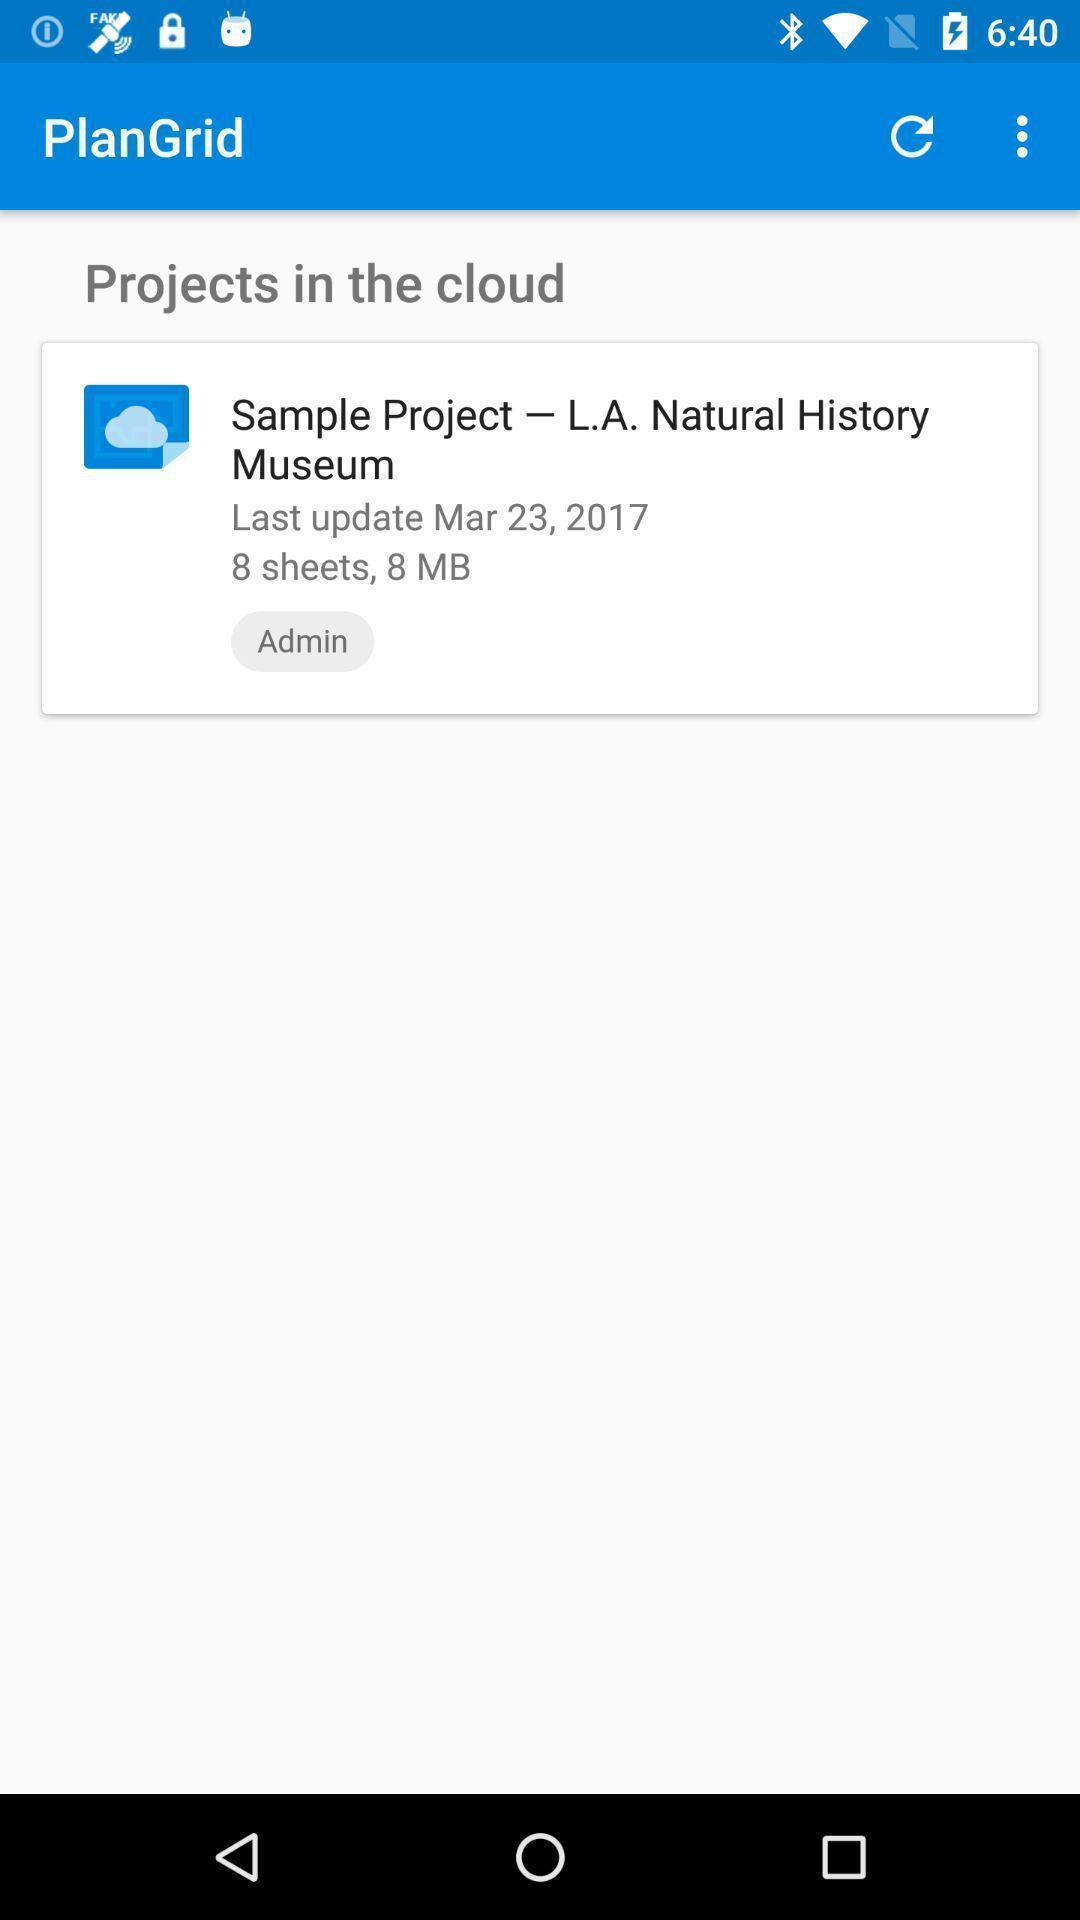What is the overall content of this screenshot? Page shows projects in the cloud details on construction app. 